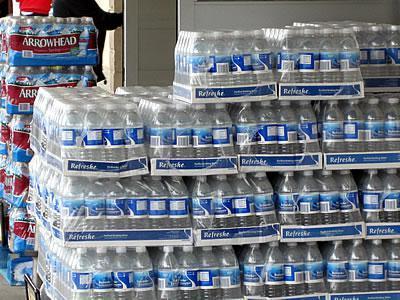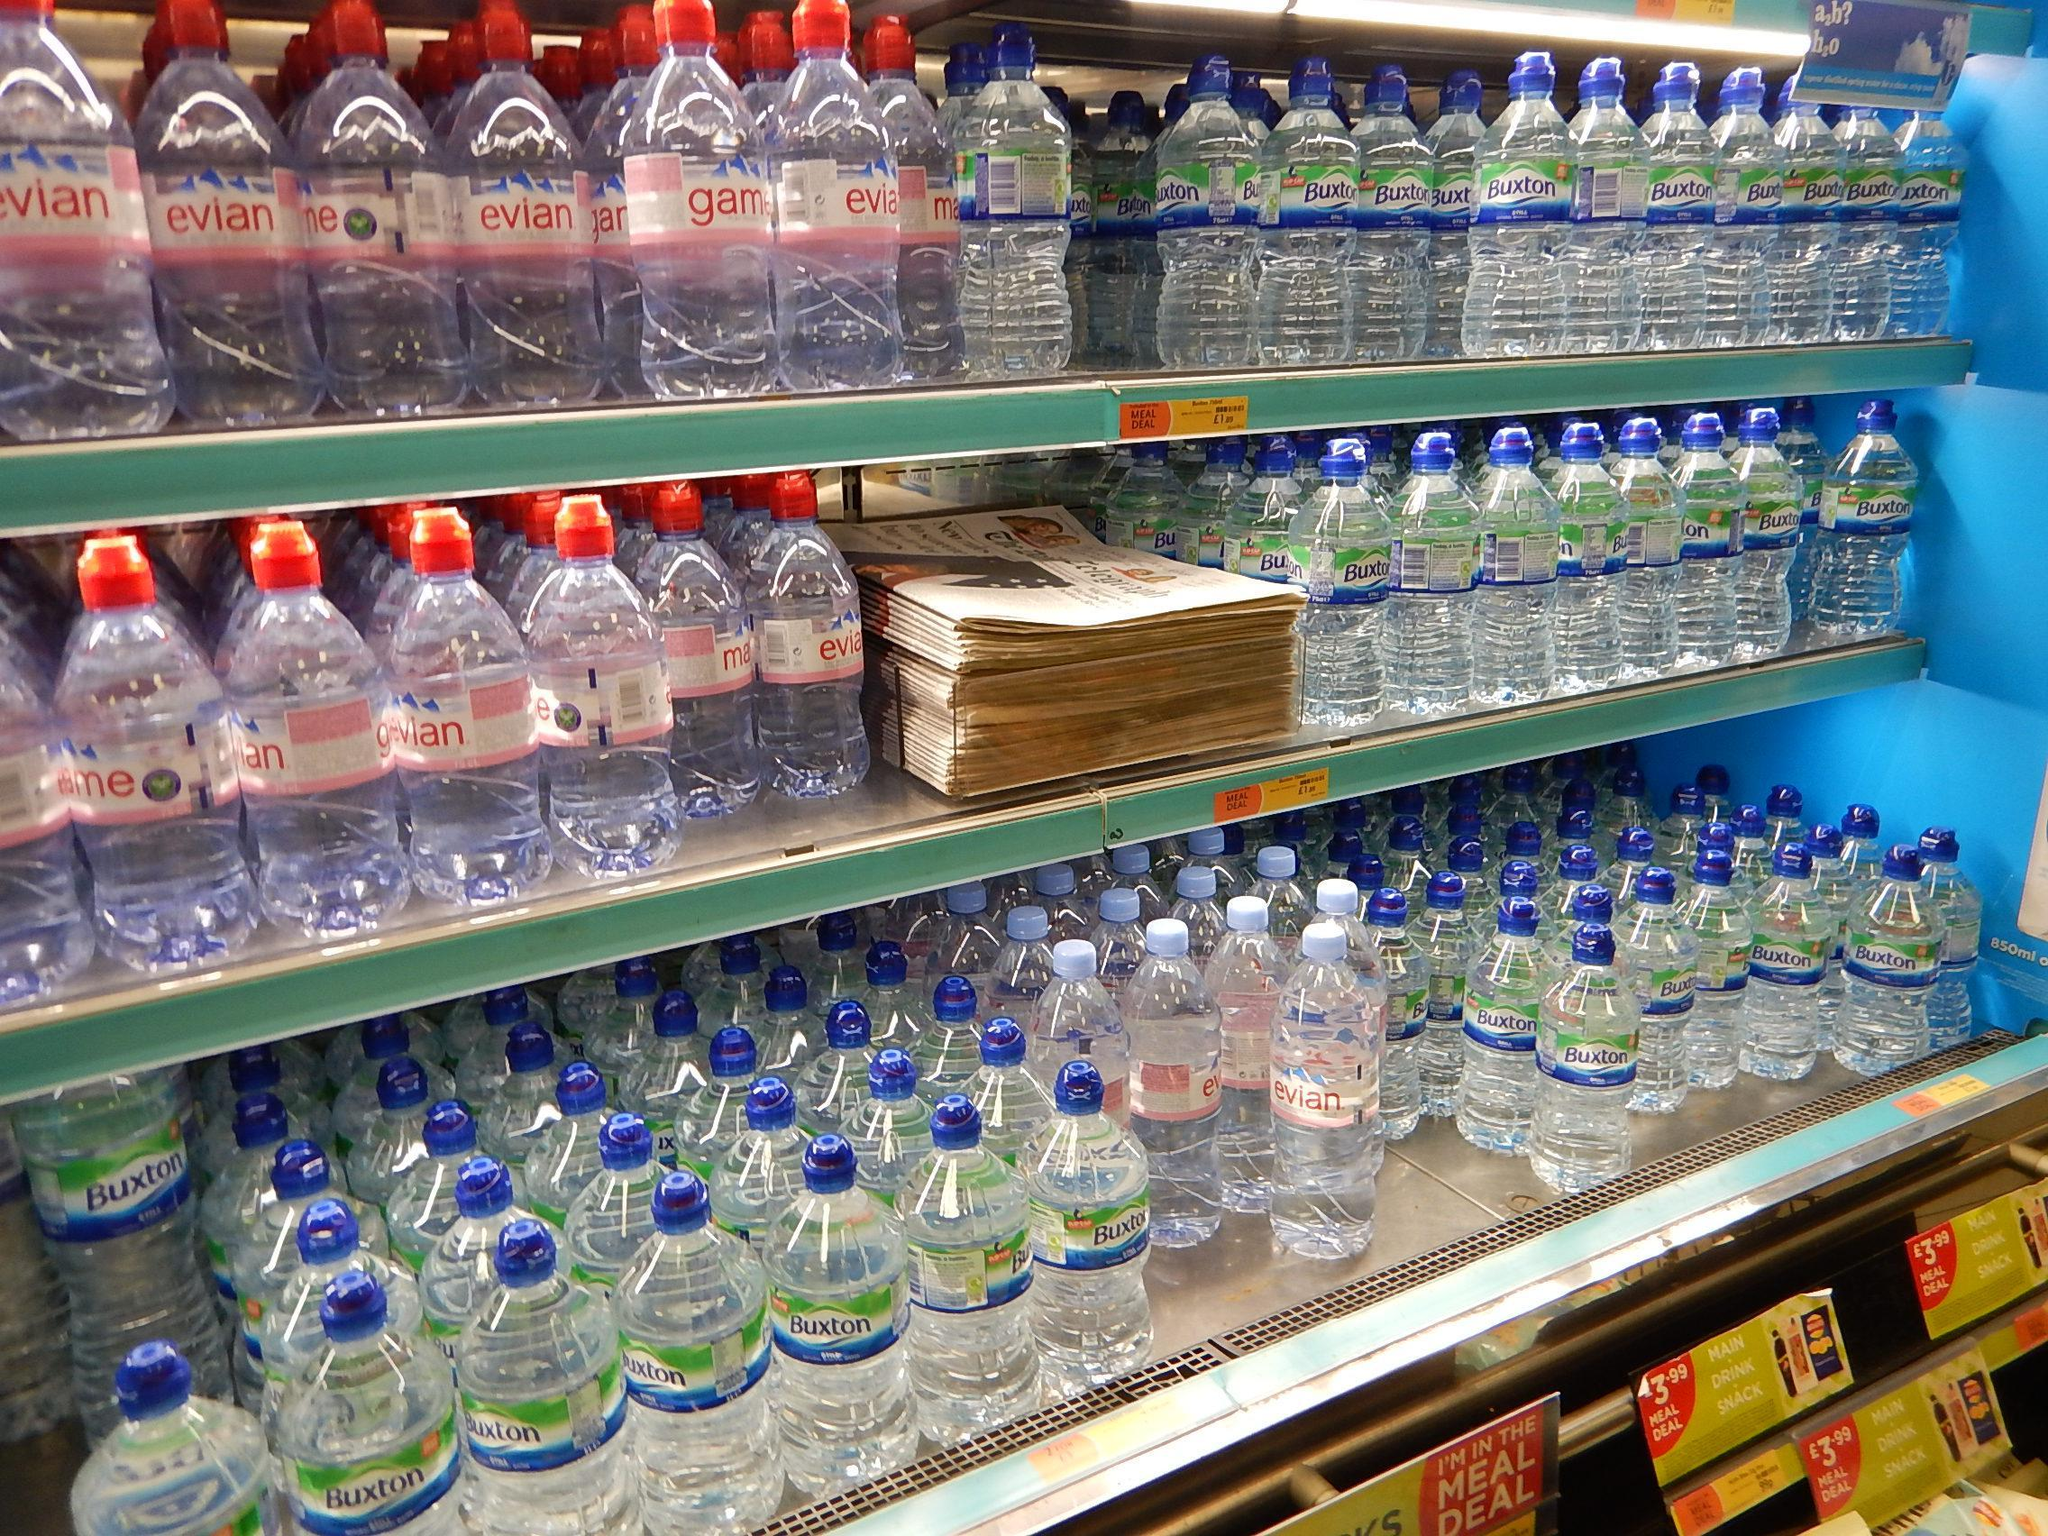The first image is the image on the left, the second image is the image on the right. Evaluate the accuracy of this statement regarding the images: "There are exactly three shelves of water bottles in the image on the left.". Is it true? Answer yes or no. No. 